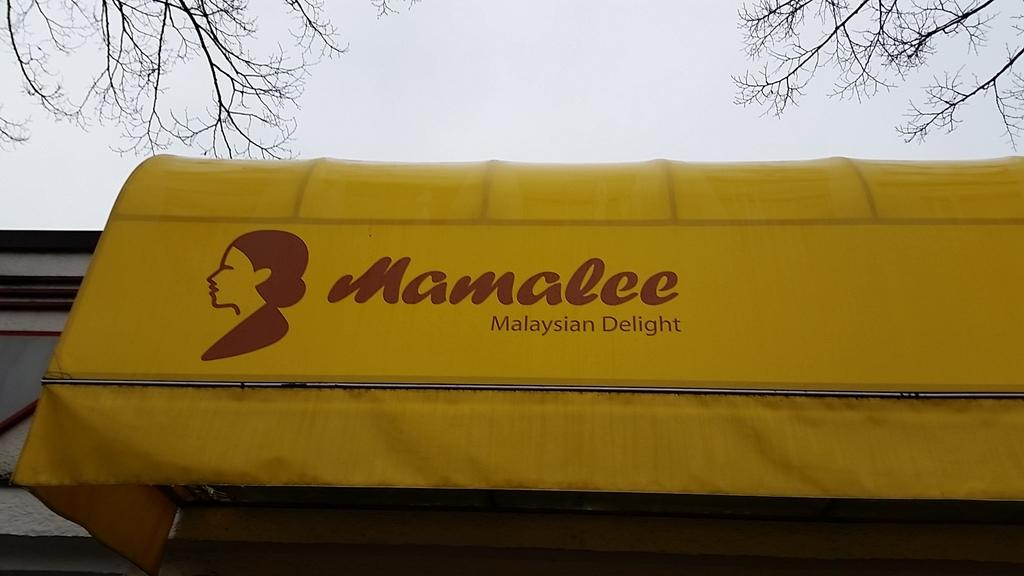What is on the wall in the image? There is a banner on a wall in the image. What can be found on the banner? The banner has text and a picture on it. What else is visible in the image besides the banner? Branches of a tree and the sky are visible in the image. What type of bird can be seen operating the machine in the image? There is no bird or machine present in the image. Can you tell me how many calculators are visible on the banner in the image? There are no calculators visible on the banner in the image. 